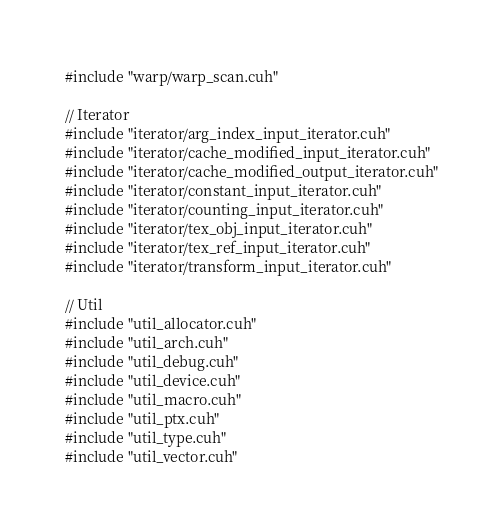<code> <loc_0><loc_0><loc_500><loc_500><_Cuda_>#include "warp/warp_scan.cuh"

// Iterator
#include "iterator/arg_index_input_iterator.cuh"
#include "iterator/cache_modified_input_iterator.cuh"
#include "iterator/cache_modified_output_iterator.cuh"
#include "iterator/constant_input_iterator.cuh"
#include "iterator/counting_input_iterator.cuh"
#include "iterator/tex_obj_input_iterator.cuh"
#include "iterator/tex_ref_input_iterator.cuh"
#include "iterator/transform_input_iterator.cuh"

// Util
#include "util_allocator.cuh"
#include "util_arch.cuh"
#include "util_debug.cuh"
#include "util_device.cuh"
#include "util_macro.cuh"
#include "util_ptx.cuh"
#include "util_type.cuh"
#include "util_vector.cuh"

</code> 